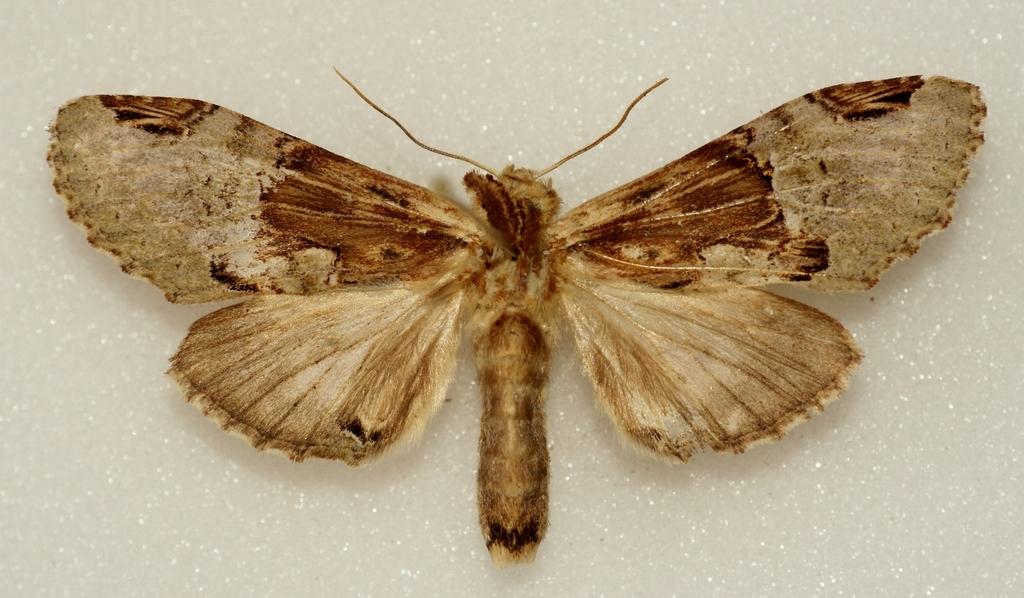What type of insect is present in the image? There is a butterfly in the image. What colors can be seen on the butterfly? The butterfly has cream and brown colors. What is the surface on which the butterfly is resting? The butterfly is on an ash-colored surface. What type of bird can be seen flying in the image? There is no bird present in the image; it features a butterfly on an ash-colored surface. What sound does the thunder make in the image? There is no thunder present in the image; it features a butterfly on an ash-colored surface. 